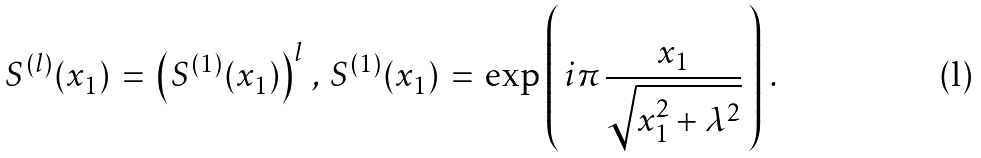Convert formula to latex. <formula><loc_0><loc_0><loc_500><loc_500>S ^ { ( l ) } ( x _ { 1 } ) \, = \, \left ( S ^ { ( 1 ) } ( x _ { 1 } ) \right ) ^ { l } \, , \, S ^ { ( 1 ) } ( x _ { 1 } ) \, = \, \exp \left ( \, i \pi \, \frac { x _ { 1 } } { \sqrt { x _ { 1 } ^ { 2 } + \lambda ^ { 2 } } } \, \right ) \, .</formula> 